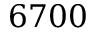Convert formula to latex. <formula><loc_0><loc_0><loc_500><loc_500>6 7 0 0</formula> 